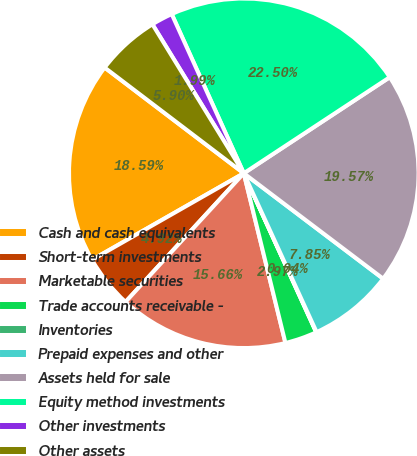<chart> <loc_0><loc_0><loc_500><loc_500><pie_chart><fcel>Cash and cash equivalents<fcel>Short-term investments<fcel>Marketable securities<fcel>Trade accounts receivable -<fcel>Inventories<fcel>Prepaid expenses and other<fcel>Assets held for sale<fcel>Equity method investments<fcel>Other investments<fcel>Other assets<nl><fcel>18.59%<fcel>4.92%<fcel>15.66%<fcel>2.97%<fcel>0.04%<fcel>7.85%<fcel>19.57%<fcel>22.5%<fcel>1.99%<fcel>5.9%<nl></chart> 